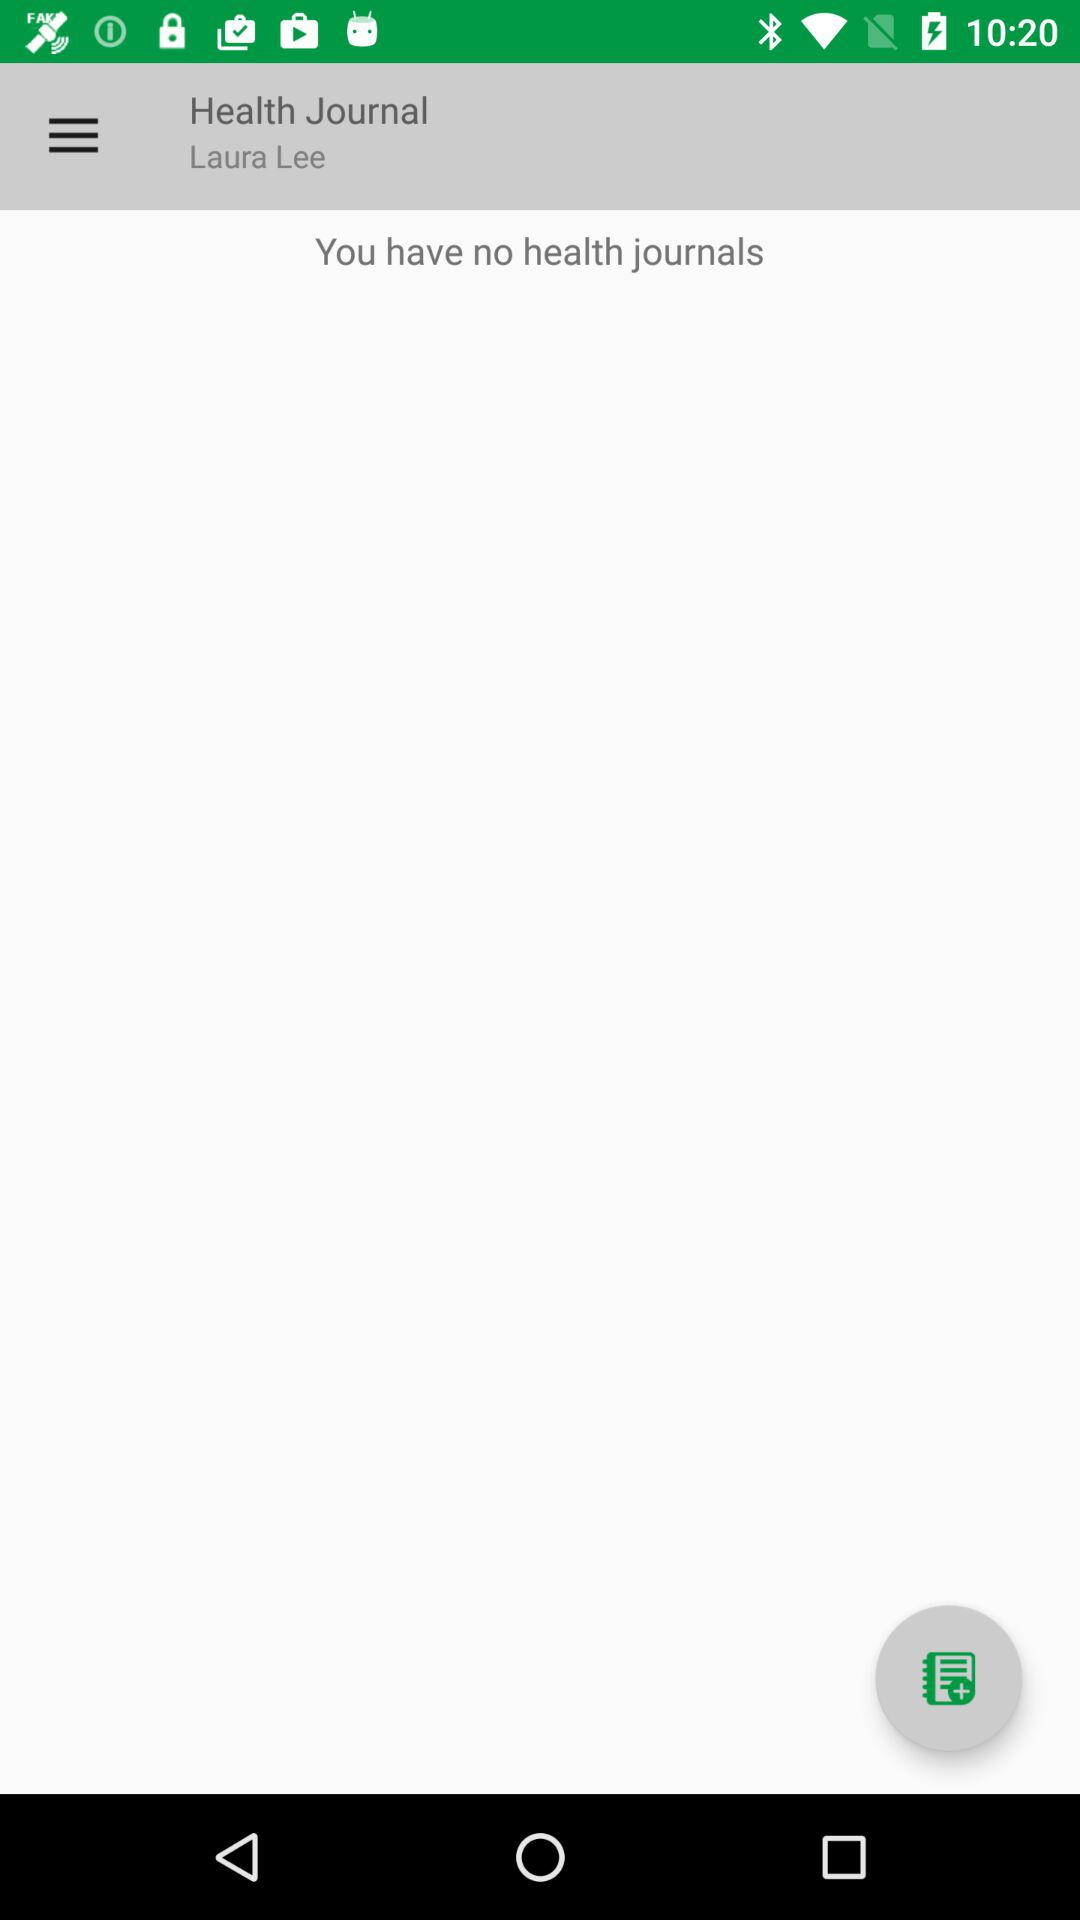How many health journals are there?
Answer the question using a single word or phrase. 0 